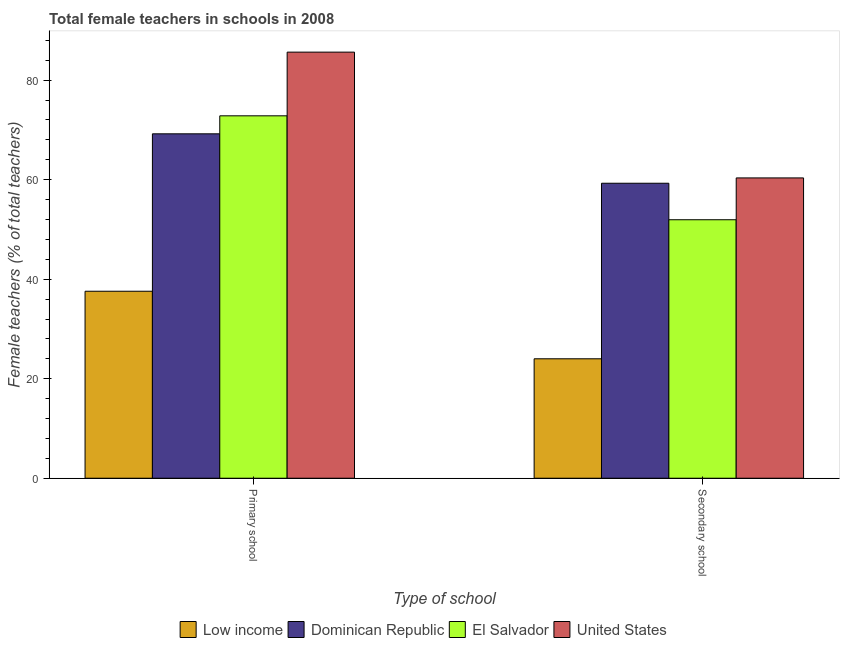How many different coloured bars are there?
Provide a short and direct response. 4. How many groups of bars are there?
Provide a short and direct response. 2. Are the number of bars per tick equal to the number of legend labels?
Keep it short and to the point. Yes. How many bars are there on the 2nd tick from the left?
Give a very brief answer. 4. How many bars are there on the 1st tick from the right?
Provide a short and direct response. 4. What is the label of the 2nd group of bars from the left?
Your answer should be very brief. Secondary school. What is the percentage of female teachers in primary schools in Low income?
Your answer should be very brief. 37.58. Across all countries, what is the maximum percentage of female teachers in primary schools?
Make the answer very short. 85.64. Across all countries, what is the minimum percentage of female teachers in primary schools?
Offer a terse response. 37.58. In which country was the percentage of female teachers in primary schools maximum?
Ensure brevity in your answer.  United States. In which country was the percentage of female teachers in primary schools minimum?
Offer a terse response. Low income. What is the total percentage of female teachers in primary schools in the graph?
Ensure brevity in your answer.  265.28. What is the difference between the percentage of female teachers in primary schools in Low income and that in Dominican Republic?
Your response must be concise. -31.64. What is the difference between the percentage of female teachers in primary schools in Dominican Republic and the percentage of female teachers in secondary schools in Low income?
Your response must be concise. 45.21. What is the average percentage of female teachers in primary schools per country?
Provide a short and direct response. 66.32. What is the difference between the percentage of female teachers in secondary schools and percentage of female teachers in primary schools in Dominican Republic?
Your answer should be compact. -9.93. What is the ratio of the percentage of female teachers in primary schools in United States to that in Dominican Republic?
Keep it short and to the point. 1.24. In how many countries, is the percentage of female teachers in primary schools greater than the average percentage of female teachers in primary schools taken over all countries?
Your answer should be compact. 3. What does the 3rd bar from the right in Primary school represents?
Make the answer very short. Dominican Republic. How many countries are there in the graph?
Your response must be concise. 4. What is the difference between two consecutive major ticks on the Y-axis?
Make the answer very short. 20. Does the graph contain any zero values?
Provide a succinct answer. No. Where does the legend appear in the graph?
Keep it short and to the point. Bottom center. How are the legend labels stacked?
Offer a very short reply. Horizontal. What is the title of the graph?
Offer a very short reply. Total female teachers in schools in 2008. Does "United Kingdom" appear as one of the legend labels in the graph?
Your answer should be compact. No. What is the label or title of the X-axis?
Your answer should be compact. Type of school. What is the label or title of the Y-axis?
Offer a very short reply. Female teachers (% of total teachers). What is the Female teachers (% of total teachers) of Low income in Primary school?
Your response must be concise. 37.58. What is the Female teachers (% of total teachers) of Dominican Republic in Primary school?
Ensure brevity in your answer.  69.22. What is the Female teachers (% of total teachers) of El Salvador in Primary school?
Provide a short and direct response. 72.84. What is the Female teachers (% of total teachers) of United States in Primary school?
Offer a very short reply. 85.64. What is the Female teachers (% of total teachers) of Low income in Secondary school?
Make the answer very short. 24. What is the Female teachers (% of total teachers) in Dominican Republic in Secondary school?
Make the answer very short. 59.29. What is the Female teachers (% of total teachers) of El Salvador in Secondary school?
Ensure brevity in your answer.  51.95. What is the Female teachers (% of total teachers) in United States in Secondary school?
Make the answer very short. 60.36. Across all Type of school, what is the maximum Female teachers (% of total teachers) in Low income?
Your answer should be compact. 37.58. Across all Type of school, what is the maximum Female teachers (% of total teachers) of Dominican Republic?
Your answer should be compact. 69.22. Across all Type of school, what is the maximum Female teachers (% of total teachers) of El Salvador?
Your response must be concise. 72.84. Across all Type of school, what is the maximum Female teachers (% of total teachers) in United States?
Keep it short and to the point. 85.64. Across all Type of school, what is the minimum Female teachers (% of total teachers) in Low income?
Your answer should be very brief. 24. Across all Type of school, what is the minimum Female teachers (% of total teachers) of Dominican Republic?
Your answer should be very brief. 59.29. Across all Type of school, what is the minimum Female teachers (% of total teachers) of El Salvador?
Your answer should be very brief. 51.95. Across all Type of school, what is the minimum Female teachers (% of total teachers) in United States?
Your response must be concise. 60.36. What is the total Female teachers (% of total teachers) of Low income in the graph?
Offer a terse response. 61.58. What is the total Female teachers (% of total teachers) in Dominican Republic in the graph?
Your answer should be compact. 128.51. What is the total Female teachers (% of total teachers) of El Salvador in the graph?
Keep it short and to the point. 124.79. What is the total Female teachers (% of total teachers) of United States in the graph?
Make the answer very short. 145.99. What is the difference between the Female teachers (% of total teachers) in Low income in Primary school and that in Secondary school?
Your answer should be very brief. 13.58. What is the difference between the Female teachers (% of total teachers) in Dominican Republic in Primary school and that in Secondary school?
Offer a terse response. 9.93. What is the difference between the Female teachers (% of total teachers) of El Salvador in Primary school and that in Secondary school?
Your answer should be compact. 20.89. What is the difference between the Female teachers (% of total teachers) in United States in Primary school and that in Secondary school?
Make the answer very short. 25.28. What is the difference between the Female teachers (% of total teachers) in Low income in Primary school and the Female teachers (% of total teachers) in Dominican Republic in Secondary school?
Provide a short and direct response. -21.71. What is the difference between the Female teachers (% of total teachers) in Low income in Primary school and the Female teachers (% of total teachers) in El Salvador in Secondary school?
Offer a very short reply. -14.37. What is the difference between the Female teachers (% of total teachers) of Low income in Primary school and the Female teachers (% of total teachers) of United States in Secondary school?
Your answer should be compact. -22.78. What is the difference between the Female teachers (% of total teachers) in Dominican Republic in Primary school and the Female teachers (% of total teachers) in El Salvador in Secondary school?
Provide a short and direct response. 17.27. What is the difference between the Female teachers (% of total teachers) in Dominican Republic in Primary school and the Female teachers (% of total teachers) in United States in Secondary school?
Your response must be concise. 8.86. What is the difference between the Female teachers (% of total teachers) of El Salvador in Primary school and the Female teachers (% of total teachers) of United States in Secondary school?
Keep it short and to the point. 12.48. What is the average Female teachers (% of total teachers) of Low income per Type of school?
Your answer should be very brief. 30.79. What is the average Female teachers (% of total teachers) in Dominican Republic per Type of school?
Offer a terse response. 64.25. What is the average Female teachers (% of total teachers) of El Salvador per Type of school?
Your response must be concise. 62.4. What is the average Female teachers (% of total teachers) of United States per Type of school?
Your answer should be compact. 73. What is the difference between the Female teachers (% of total teachers) of Low income and Female teachers (% of total teachers) of Dominican Republic in Primary school?
Offer a terse response. -31.64. What is the difference between the Female teachers (% of total teachers) of Low income and Female teachers (% of total teachers) of El Salvador in Primary school?
Your response must be concise. -35.26. What is the difference between the Female teachers (% of total teachers) of Low income and Female teachers (% of total teachers) of United States in Primary school?
Provide a succinct answer. -48.06. What is the difference between the Female teachers (% of total teachers) in Dominican Republic and Female teachers (% of total teachers) in El Salvador in Primary school?
Offer a terse response. -3.62. What is the difference between the Female teachers (% of total teachers) in Dominican Republic and Female teachers (% of total teachers) in United States in Primary school?
Provide a succinct answer. -16.42. What is the difference between the Female teachers (% of total teachers) of El Salvador and Female teachers (% of total teachers) of United States in Primary school?
Provide a short and direct response. -12.8. What is the difference between the Female teachers (% of total teachers) in Low income and Female teachers (% of total teachers) in Dominican Republic in Secondary school?
Offer a terse response. -35.28. What is the difference between the Female teachers (% of total teachers) of Low income and Female teachers (% of total teachers) of El Salvador in Secondary school?
Ensure brevity in your answer.  -27.95. What is the difference between the Female teachers (% of total teachers) in Low income and Female teachers (% of total teachers) in United States in Secondary school?
Make the answer very short. -36.35. What is the difference between the Female teachers (% of total teachers) in Dominican Republic and Female teachers (% of total teachers) in El Salvador in Secondary school?
Provide a succinct answer. 7.34. What is the difference between the Female teachers (% of total teachers) in Dominican Republic and Female teachers (% of total teachers) in United States in Secondary school?
Provide a succinct answer. -1.07. What is the difference between the Female teachers (% of total teachers) in El Salvador and Female teachers (% of total teachers) in United States in Secondary school?
Keep it short and to the point. -8.4. What is the ratio of the Female teachers (% of total teachers) of Low income in Primary school to that in Secondary school?
Give a very brief answer. 1.57. What is the ratio of the Female teachers (% of total teachers) of Dominican Republic in Primary school to that in Secondary school?
Give a very brief answer. 1.17. What is the ratio of the Female teachers (% of total teachers) in El Salvador in Primary school to that in Secondary school?
Keep it short and to the point. 1.4. What is the ratio of the Female teachers (% of total teachers) in United States in Primary school to that in Secondary school?
Give a very brief answer. 1.42. What is the difference between the highest and the second highest Female teachers (% of total teachers) of Low income?
Your answer should be very brief. 13.58. What is the difference between the highest and the second highest Female teachers (% of total teachers) in Dominican Republic?
Give a very brief answer. 9.93. What is the difference between the highest and the second highest Female teachers (% of total teachers) in El Salvador?
Give a very brief answer. 20.89. What is the difference between the highest and the second highest Female teachers (% of total teachers) in United States?
Your answer should be compact. 25.28. What is the difference between the highest and the lowest Female teachers (% of total teachers) of Low income?
Offer a very short reply. 13.58. What is the difference between the highest and the lowest Female teachers (% of total teachers) of Dominican Republic?
Ensure brevity in your answer.  9.93. What is the difference between the highest and the lowest Female teachers (% of total teachers) of El Salvador?
Make the answer very short. 20.89. What is the difference between the highest and the lowest Female teachers (% of total teachers) of United States?
Offer a very short reply. 25.28. 